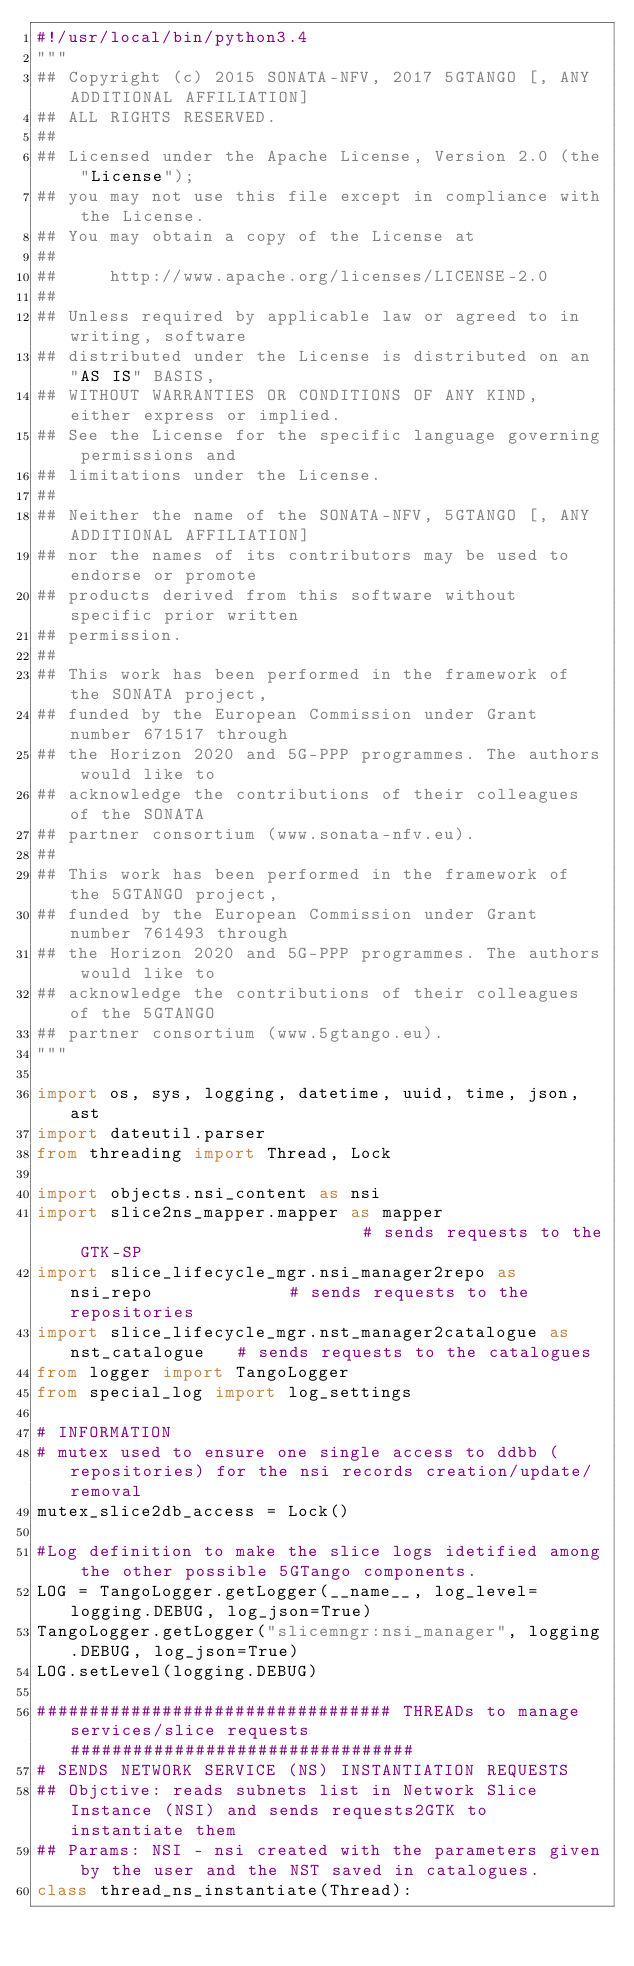<code> <loc_0><loc_0><loc_500><loc_500><_Python_>#!/usr/local/bin/python3.4
"""
## Copyright (c) 2015 SONATA-NFV, 2017 5GTANGO [, ANY ADDITIONAL AFFILIATION]
## ALL RIGHTS RESERVED.
##
## Licensed under the Apache License, Version 2.0 (the "License");
## you may not use this file except in compliance with the License.
## You may obtain a copy of the License at
##
##     http://www.apache.org/licenses/LICENSE-2.0
##
## Unless required by applicable law or agreed to in writing, software
## distributed under the License is distributed on an "AS IS" BASIS,
## WITHOUT WARRANTIES OR CONDITIONS OF ANY KIND, either express or implied.
## See the License for the specific language governing permissions and
## limitations under the License.
##
## Neither the name of the SONATA-NFV, 5GTANGO [, ANY ADDITIONAL AFFILIATION]
## nor the names of its contributors may be used to endorse or promote
## products derived from this software without specific prior written
## permission.
##
## This work has been performed in the framework of the SONATA project,
## funded by the European Commission under Grant number 671517 through
## the Horizon 2020 and 5G-PPP programmes. The authors would like to
## acknowledge the contributions of their colleagues of the SONATA
## partner consortium (www.sonata-nfv.eu).
##
## This work has been performed in the framework of the 5GTANGO project,
## funded by the European Commission under Grant number 761493 through
## the Horizon 2020 and 5G-PPP programmes. The authors would like to
## acknowledge the contributions of their colleagues of the 5GTANGO
## partner consortium (www.5gtango.eu).
"""

import os, sys, logging, datetime, uuid, time, json, ast
import dateutil.parser
from threading import Thread, Lock

import objects.nsi_content as nsi
import slice2ns_mapper.mapper as mapper                             # sends requests to the GTK-SP
import slice_lifecycle_mgr.nsi_manager2repo as nsi_repo             # sends requests to the repositories
import slice_lifecycle_mgr.nst_manager2catalogue as nst_catalogue   # sends requests to the catalogues
from logger import TangoLogger
from special_log import log_settings

# INFORMATION
# mutex used to ensure one single access to ddbb (repositories) for the nsi records creation/update/removal
mutex_slice2db_access = Lock()

#Log definition to make the slice logs idetified among the other possible 5GTango components.
LOG = TangoLogger.getLogger(__name__, log_level=logging.DEBUG, log_json=True)
TangoLogger.getLogger("slicemngr:nsi_manager", logging.DEBUG, log_json=True)
LOG.setLevel(logging.DEBUG)

################################## THREADs to manage services/slice requests #################################
# SENDS NETWORK SERVICE (NS) INSTANTIATION REQUESTS
## Objctive: reads subnets list in Network Slice Instance (NSI) and sends requests2GTK to instantiate them 
## Params: NSI - nsi created with the parameters given by the user and the NST saved in catalogues.
class thread_ns_instantiate(Thread):</code> 